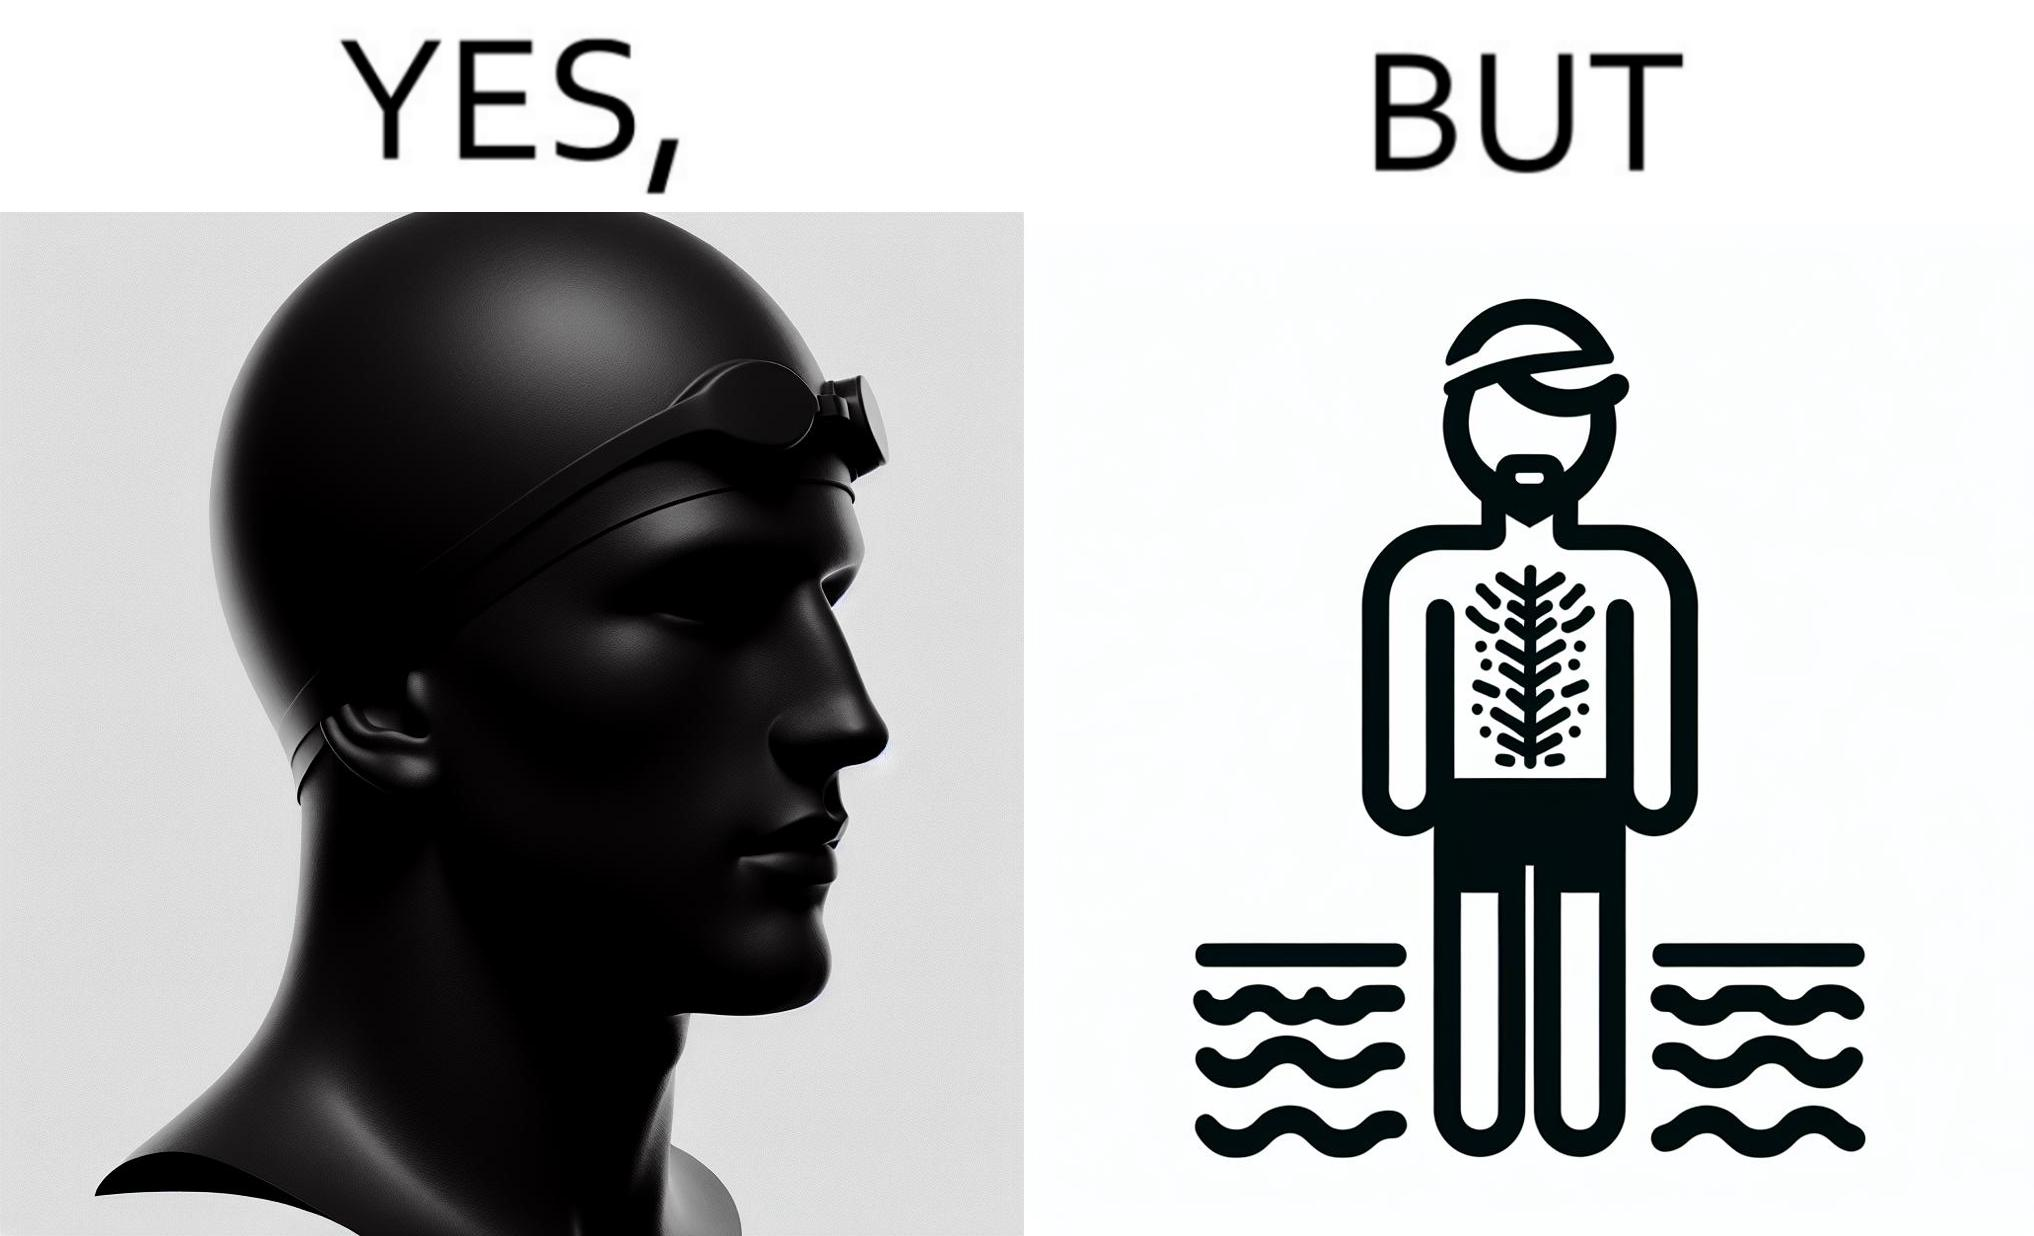Describe the content of this image. The man is wearing a swimming cap to protect his head's hair but on the other side he is not concerned over the hair all over his body and is nowhere covering them 